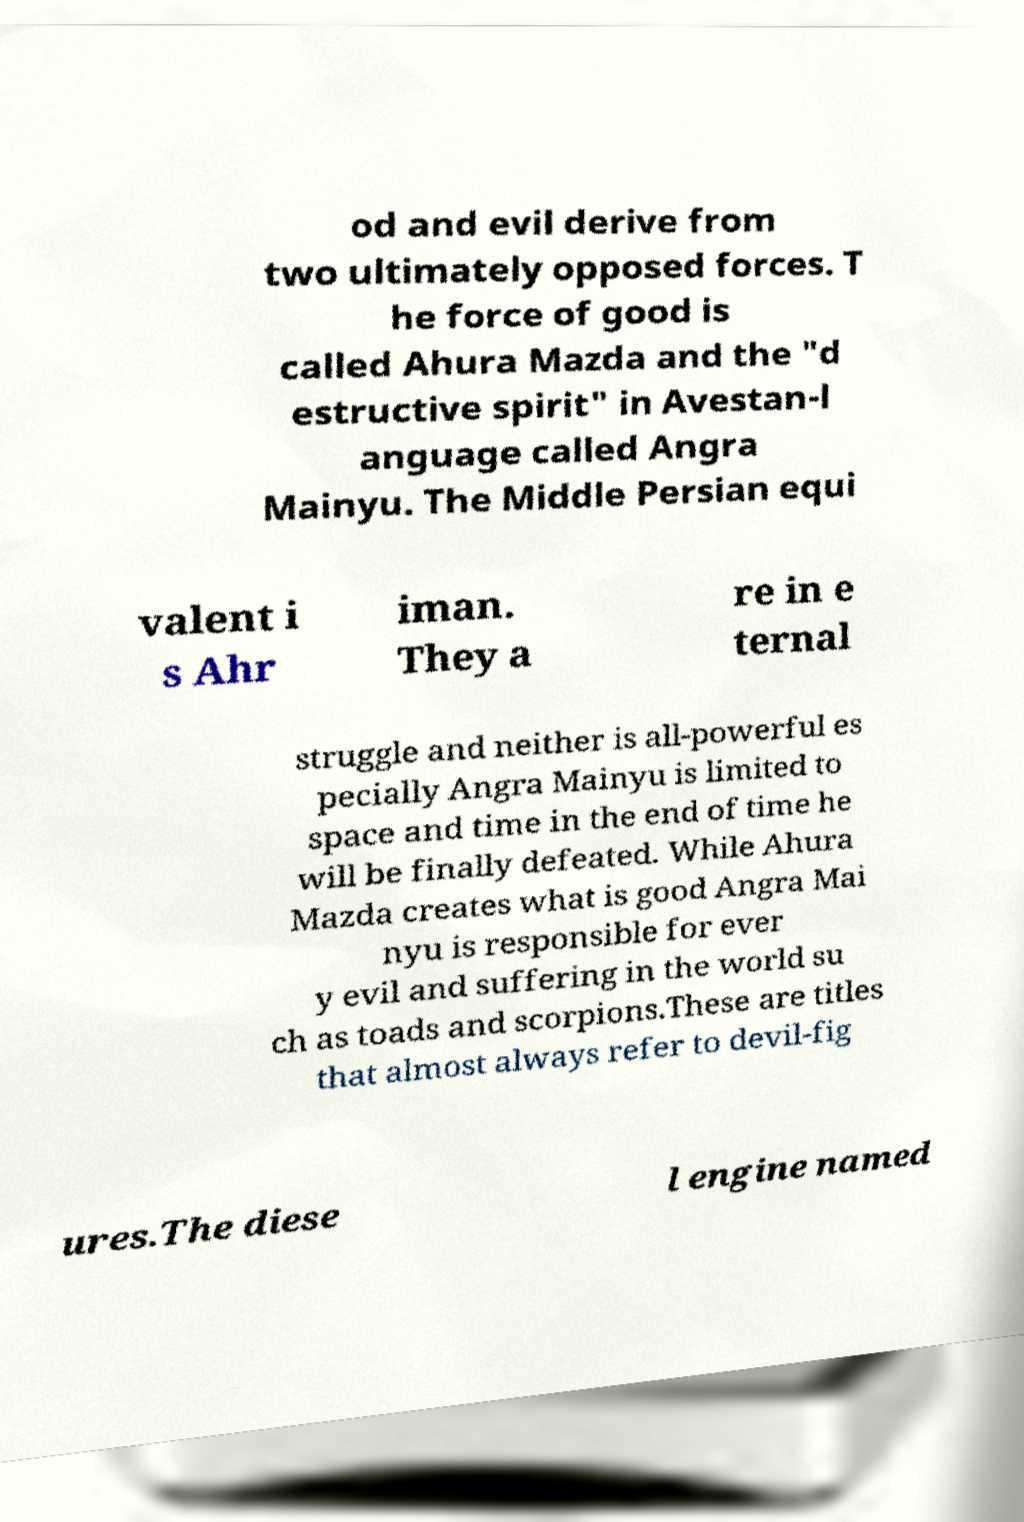Can you read and provide the text displayed in the image?This photo seems to have some interesting text. Can you extract and type it out for me? od and evil derive from two ultimately opposed forces. T he force of good is called Ahura Mazda and the "d estructive spirit" in Avestan-l anguage called Angra Mainyu. The Middle Persian equi valent i s Ahr iman. They a re in e ternal struggle and neither is all-powerful es pecially Angra Mainyu is limited to space and time in the end of time he will be finally defeated. While Ahura Mazda creates what is good Angra Mai nyu is responsible for ever y evil and suffering in the world su ch as toads and scorpions.These are titles that almost always refer to devil-fig ures.The diese l engine named 